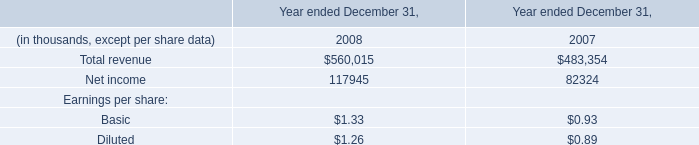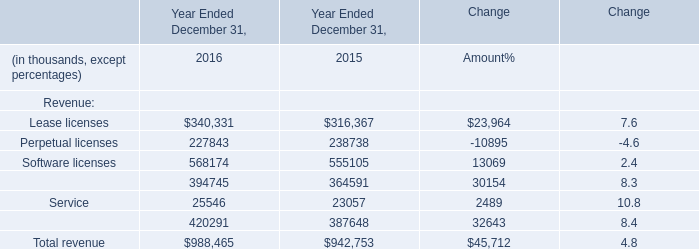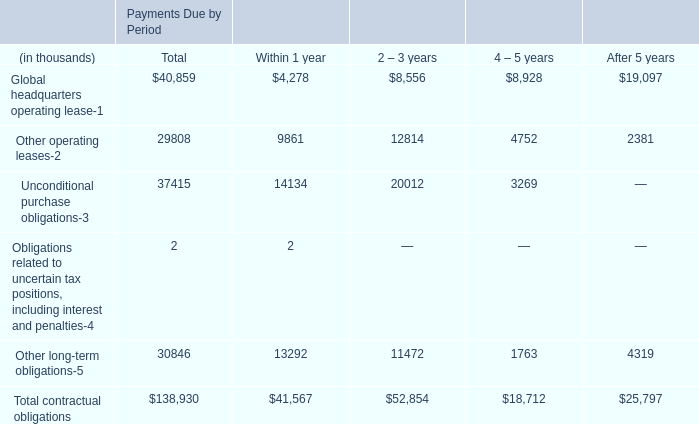What is the proportion of Lease licenses to the total in 2016? 
Computations: (340331 / 988465)
Answer: 0.3443. 